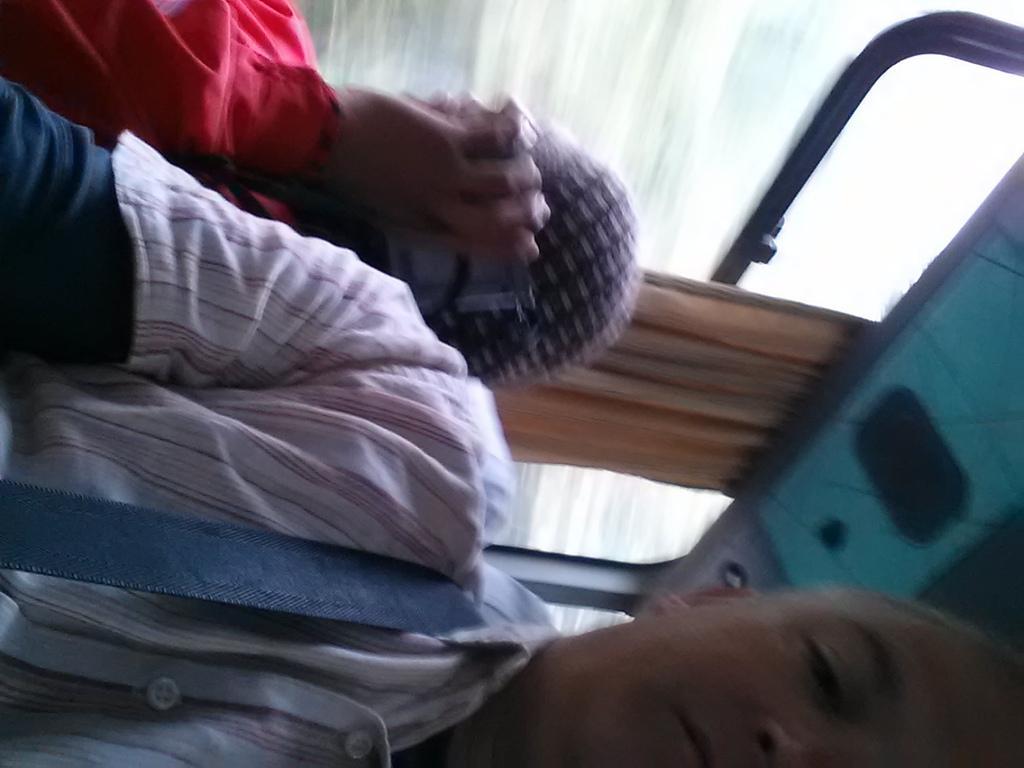Could you give a brief overview of what you see in this image? In this picture we can see there are two persons sitting in a vehicle. Behind the people, there is a curtain and a window. 